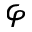Convert formula to latex. <formula><loc_0><loc_0><loc_500><loc_500>\varphi</formula> 